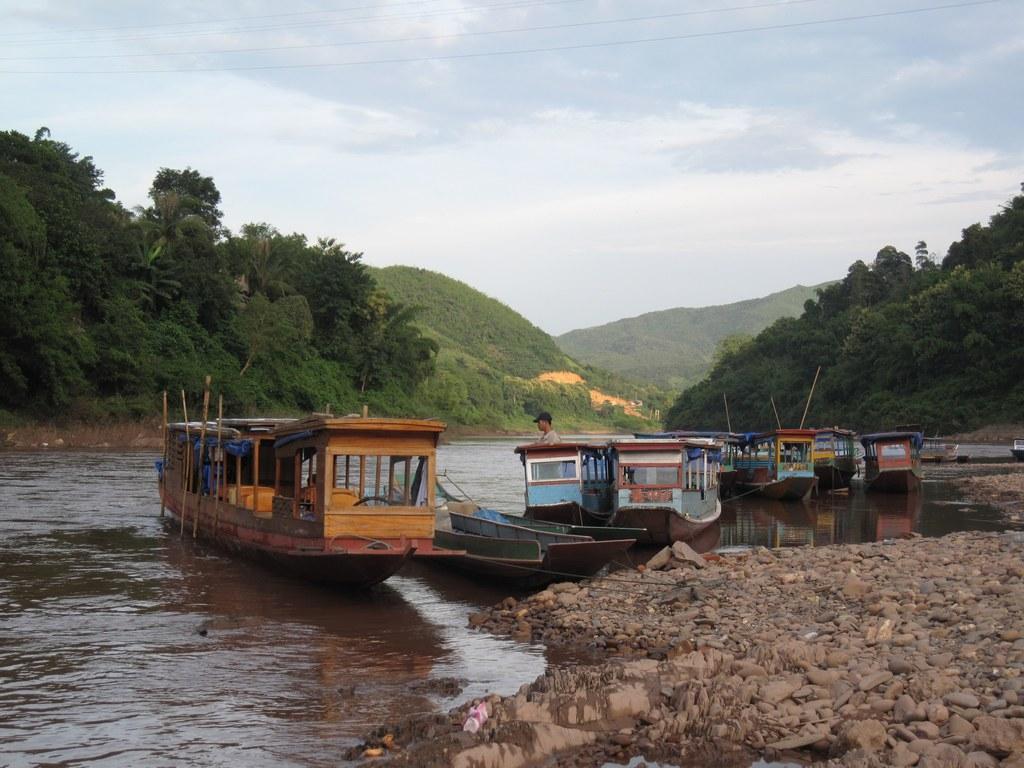Describe this image in one or two sentences. In this picture I can see there are few boats sailing on the water and there are mountains in the backdrop and the sky is clear. 